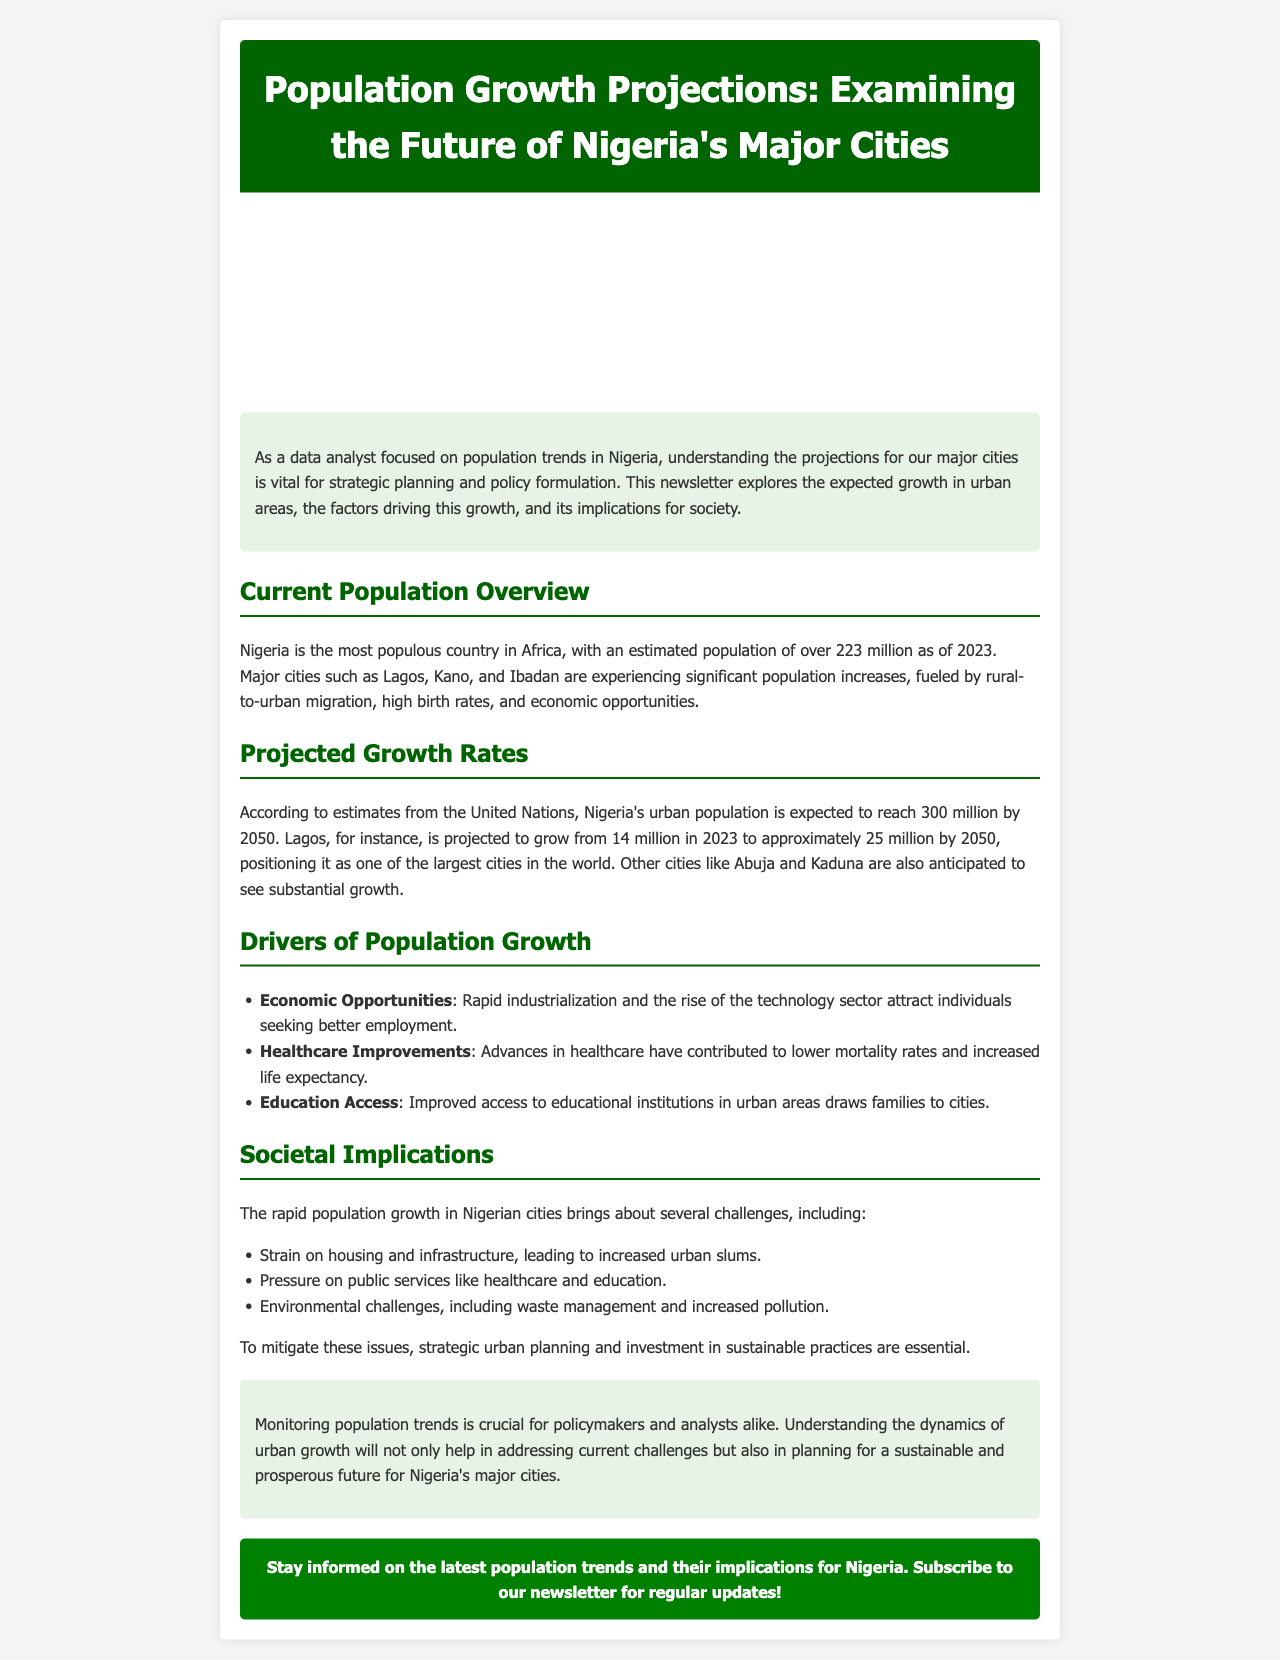What is the estimated population of Nigeria in 2023? The document states that Nigeria has an estimated population of over 223 million as of 2023.
Answer: over 223 million What city is projected to grow to approximately 25 million by 2050? The newsletter mentions that Lagos is projected to grow from 14 million in 2023 to approximately 25 million by 2050.
Answer: Lagos What are two drivers of population growth mentioned in the document? The document lists economic opportunities and healthcare improvements as drivers of population growth.
Answer: Economic Opportunities, Healthcare Improvements What kind of challenges does rapid population growth bring to Nigerian cities? The document outlines challenges such as strain on housing and infrastructure, pressure on public services, and environmental challenges.
Answer: Strain on housing and infrastructure, pressure on public services, environmental challenges What is the expected urban population of Nigeria by 2050? According to the estimates, Nigeria's urban population is expected to reach 300 million by 2050.
Answer: 300 million Why is monitoring population trends crucial? The conclusion emphasizes that monitoring population trends helps in addressing current challenges and planning for a sustainable future.
Answer: Addressing current challenges and planning for a sustainable future What type of image is included in the newsletter? The document describes a city image that visually represents the content of the newsletter.
Answer: City image Which city is specifically mentioned along with Lagos in terms of projected growth? The newsletter mentions Abuja along with Lagos as a city expected to see substantial growth.
Answer: Abuja 